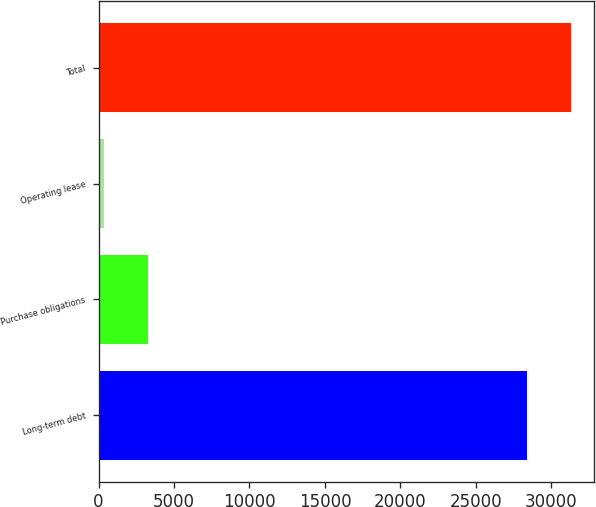Convert chart. <chart><loc_0><loc_0><loc_500><loc_500><bar_chart><fcel>Long-term debt<fcel>Purchase obligations<fcel>Operating lease<fcel>Total<nl><fcel>28391<fcel>3281.3<fcel>384<fcel>31288.3<nl></chart> 